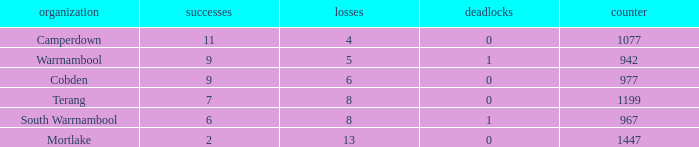What's the number of losses when the wins were more than 11 and had 0 draws? 0.0. 